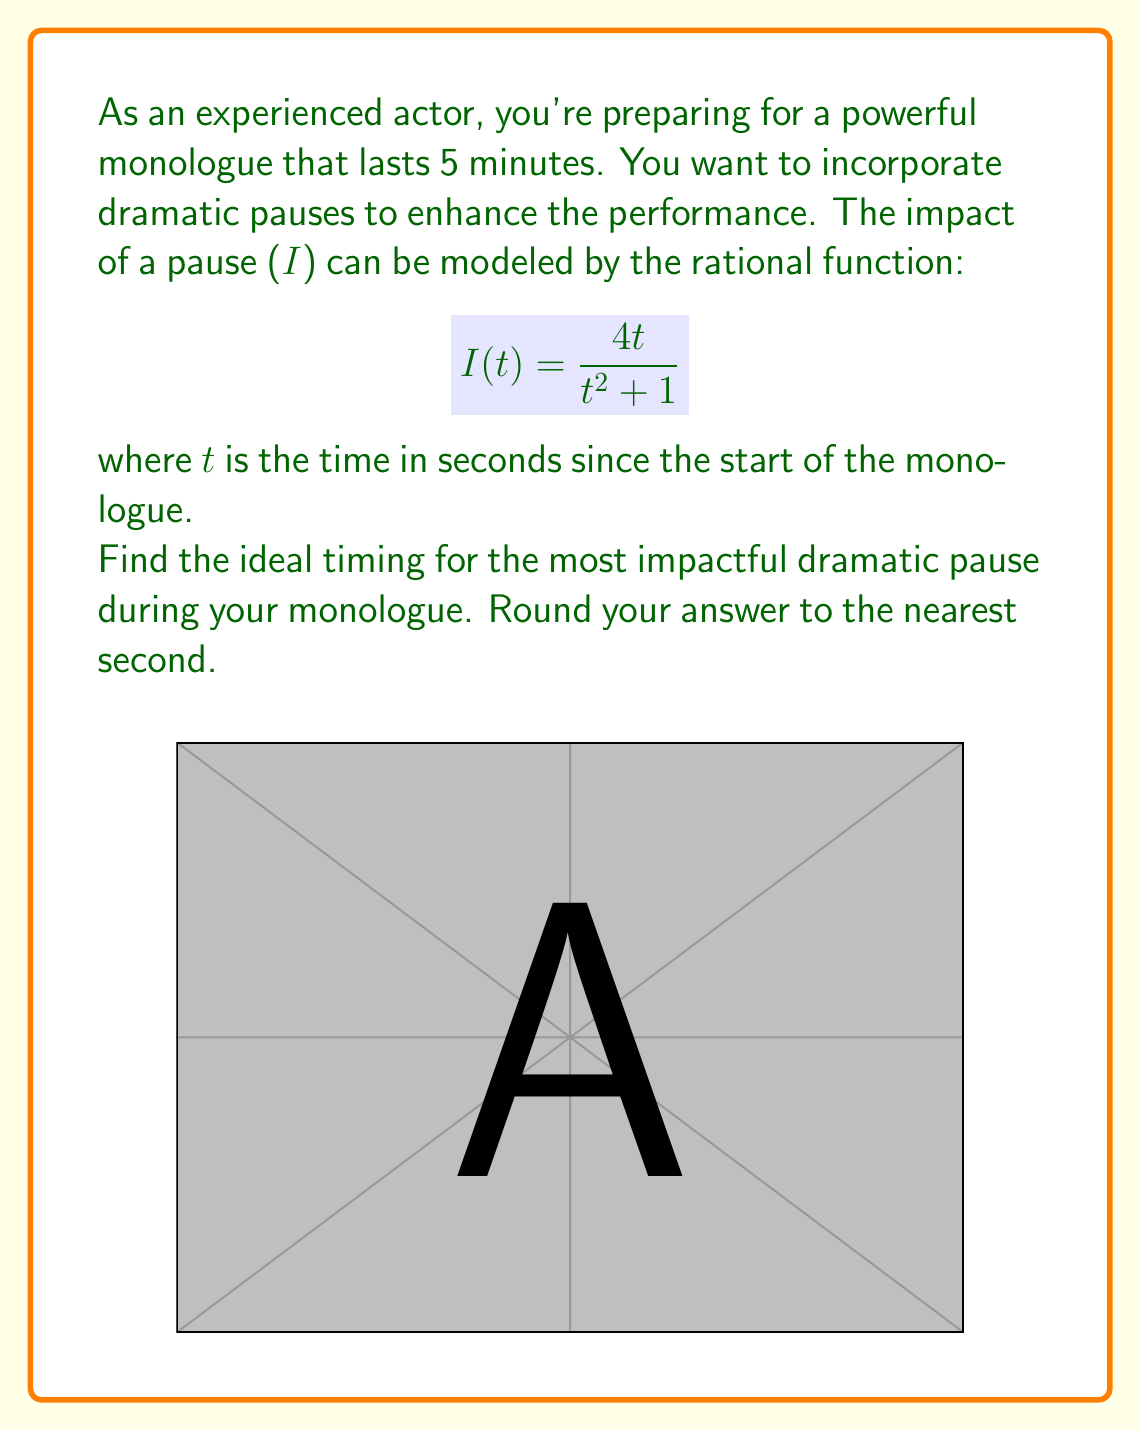Solve this math problem. Let's approach this step-by-step:

1) The impact function $I(t) = \frac{4t}{t^2 + 1}$ is a rational function.

2) To find the maximum impact, we need to find the critical points. We can do this by taking the derivative and setting it equal to zero.

3) Using the quotient rule, the derivative is:
   $$I'(t) = \frac{(t^2 + 1)(4) - 4t(2t)}{(t^2 + 1)^2} = \frac{4t^2 + 4 - 8t^2}{(t^2 + 1)^2} = \frac{4 - 4t^2}{(t^2 + 1)^2}$$

4) Set this equal to zero and solve:
   $$\frac{4 - 4t^2}{(t^2 + 1)^2} = 0$$
   $$4 - 4t^2 = 0$$
   $$4 = 4t^2$$
   $$1 = t^2$$
   $$t = \pm 1$$

5) Since time can't be negative in this context, our critical point is at t = 1.

6) To confirm this is a maximum, we could check the second derivative or observe the function's behavior.

7) Now, we need to convert this to minutes. 1 second = 1/60 minutes.
   $$\frac{1}{60} \approx 0.0167 \text{ minutes}$$

8) Rounding to the nearest second, the ideal timing remains at 1 second.
Answer: 1 second 